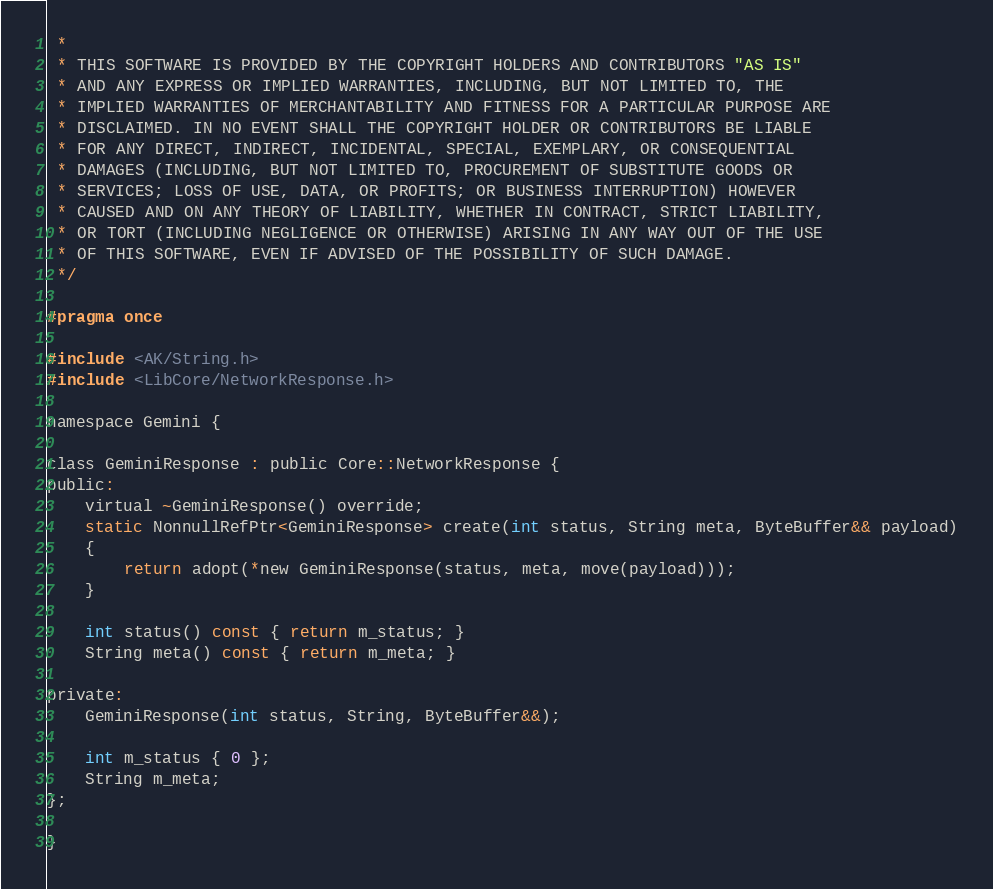Convert code to text. <code><loc_0><loc_0><loc_500><loc_500><_C_> *
 * THIS SOFTWARE IS PROVIDED BY THE COPYRIGHT HOLDERS AND CONTRIBUTORS "AS IS"
 * AND ANY EXPRESS OR IMPLIED WARRANTIES, INCLUDING, BUT NOT LIMITED TO, THE
 * IMPLIED WARRANTIES OF MERCHANTABILITY AND FITNESS FOR A PARTICULAR PURPOSE ARE
 * DISCLAIMED. IN NO EVENT SHALL THE COPYRIGHT HOLDER OR CONTRIBUTORS BE LIABLE
 * FOR ANY DIRECT, INDIRECT, INCIDENTAL, SPECIAL, EXEMPLARY, OR CONSEQUENTIAL
 * DAMAGES (INCLUDING, BUT NOT LIMITED TO, PROCUREMENT OF SUBSTITUTE GOODS OR
 * SERVICES; LOSS OF USE, DATA, OR PROFITS; OR BUSINESS INTERRUPTION) HOWEVER
 * CAUSED AND ON ANY THEORY OF LIABILITY, WHETHER IN CONTRACT, STRICT LIABILITY,
 * OR TORT (INCLUDING NEGLIGENCE OR OTHERWISE) ARISING IN ANY WAY OUT OF THE USE
 * OF THIS SOFTWARE, EVEN IF ADVISED OF THE POSSIBILITY OF SUCH DAMAGE.
 */

#pragma once

#include <AK/String.h>
#include <LibCore/NetworkResponse.h>

namespace Gemini {

class GeminiResponse : public Core::NetworkResponse {
public:
    virtual ~GeminiResponse() override;
    static NonnullRefPtr<GeminiResponse> create(int status, String meta, ByteBuffer&& payload)
    {
        return adopt(*new GeminiResponse(status, meta, move(payload)));
    }

    int status() const { return m_status; }
    String meta() const { return m_meta; }

private:
    GeminiResponse(int status, String, ByteBuffer&&);

    int m_status { 0 };
    String m_meta;
};

}
</code> 